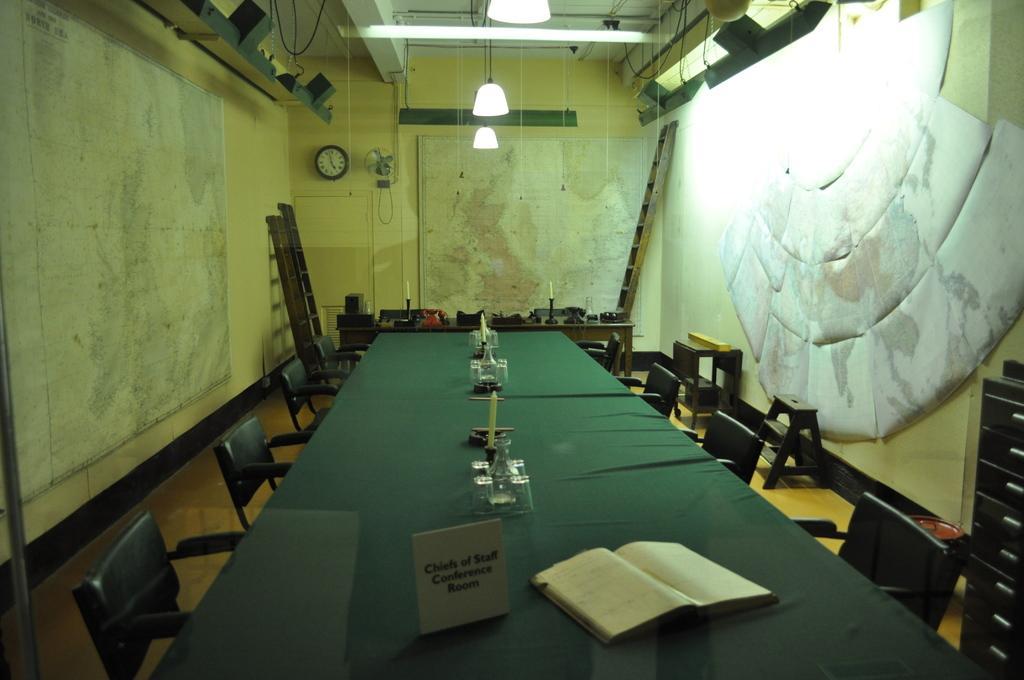How would you summarize this image in a sentence or two? In this image I can see few chairs, they are in green color. I can also see few candles, books on the table, background I can see a board attached to the wall and the wall is in cream color. 